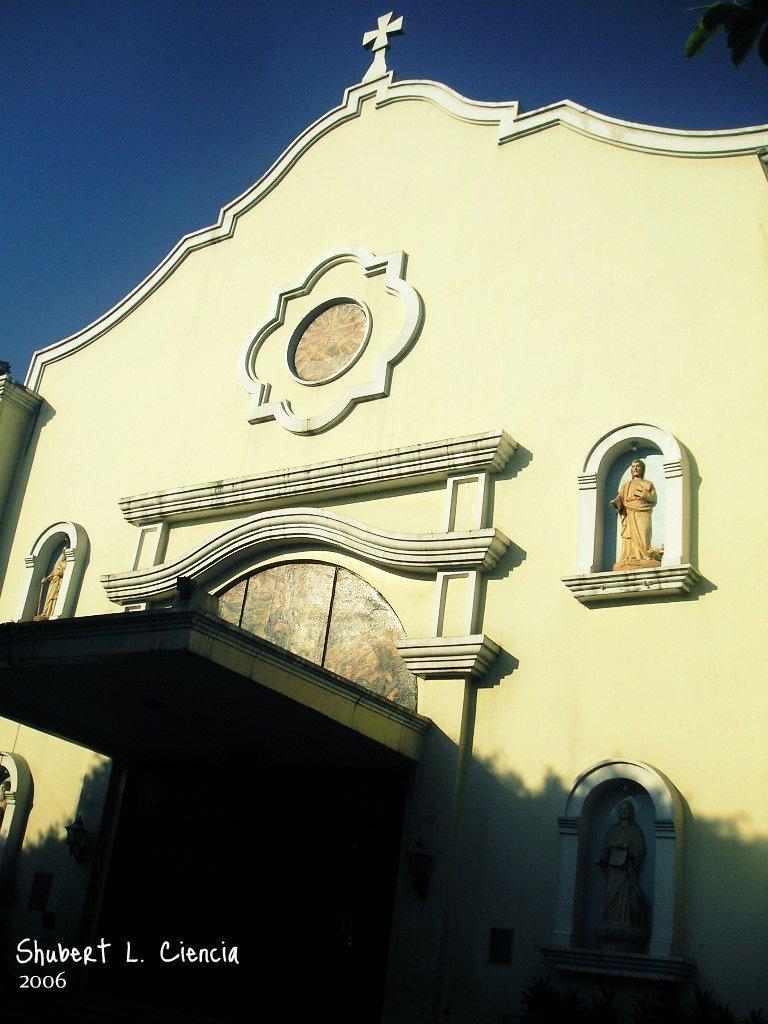Could you give a brief overview of what you see in this image? In this image, there is a church contains sculptures on the wall. There is a sky at the top of the image. 